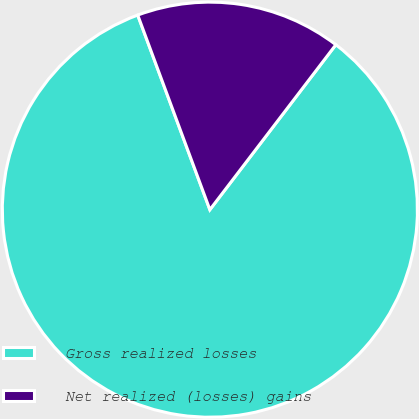Convert chart. <chart><loc_0><loc_0><loc_500><loc_500><pie_chart><fcel>Gross realized losses<fcel>Net realized (losses) gains<nl><fcel>83.97%<fcel>16.03%<nl></chart> 